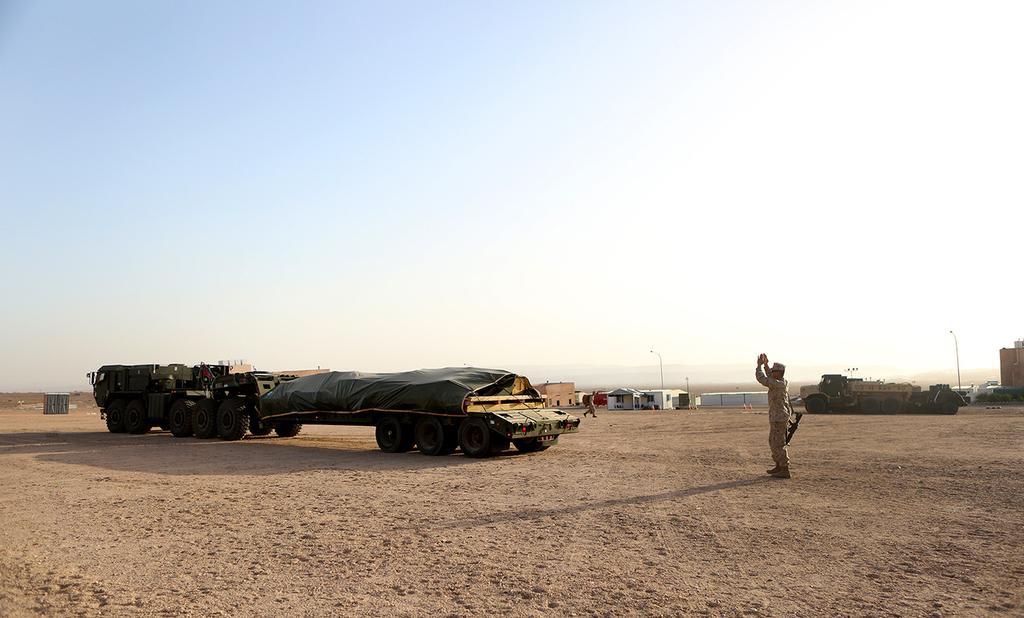Please provide a concise description of this image. In this picture, we can see a man is standing on the path and on the path there are some vehicles and a man is walking on the path. Behind the people there are houses, poles and sky. 